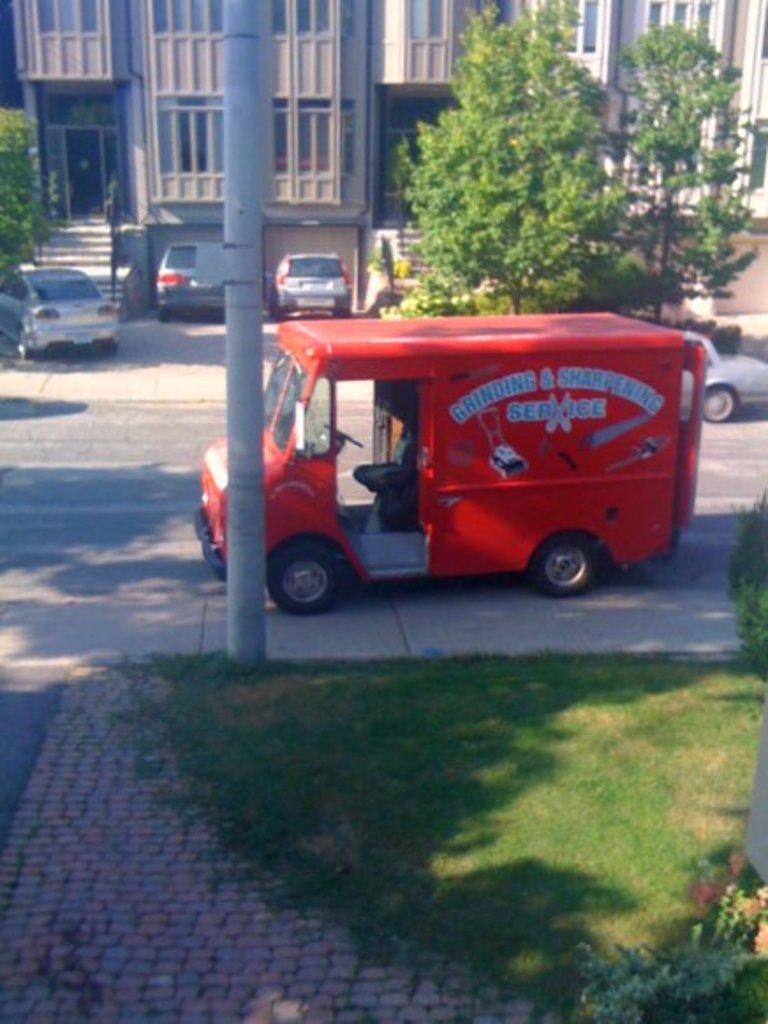What can be seen on the road in the image? There are vehicles on the road in the image. What type of natural elements can be seen in the background of the image? There are trees in the background of the image. What type of man-made structures can be seen in the background of the image? There are buildings in the background of the image. What type of vertical structures can be seen in the background of the image? There are poles in the background of the image. How many shoes are hanging from the trees in the image? There are no shoes hanging from the trees in the image. What type of animals can be seen grazing in the background of the image? There are no animals, such as cows, present in the image. 